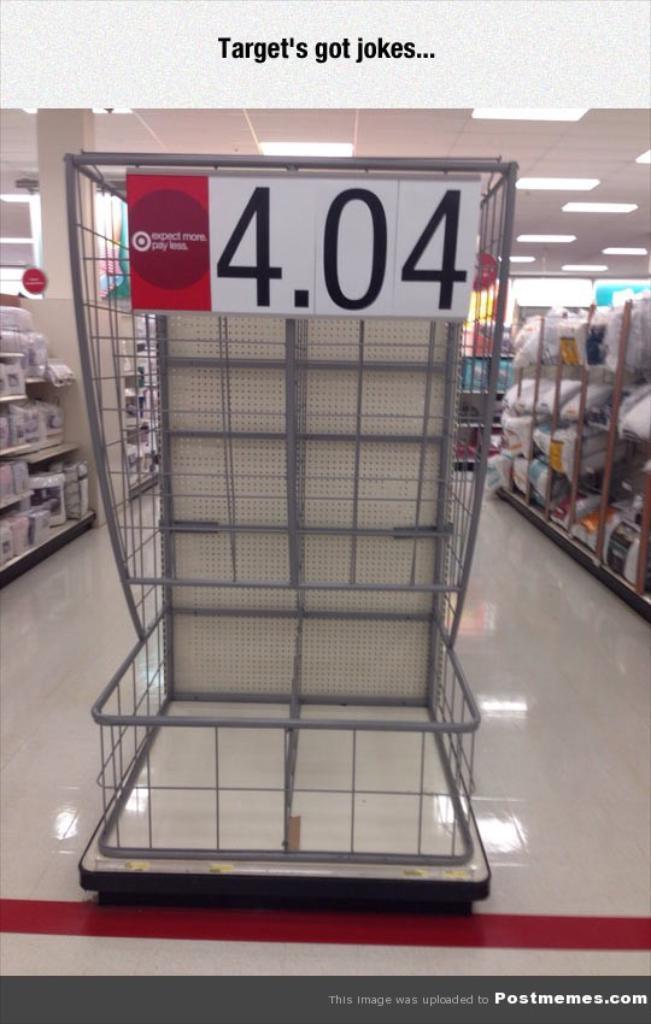In one or two sentences, can you explain what this image depicts? In this image it is looking like a tray. There is some text. On either side of the image I can see few racks. 